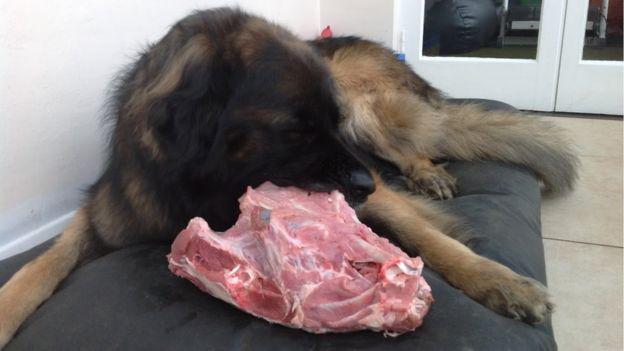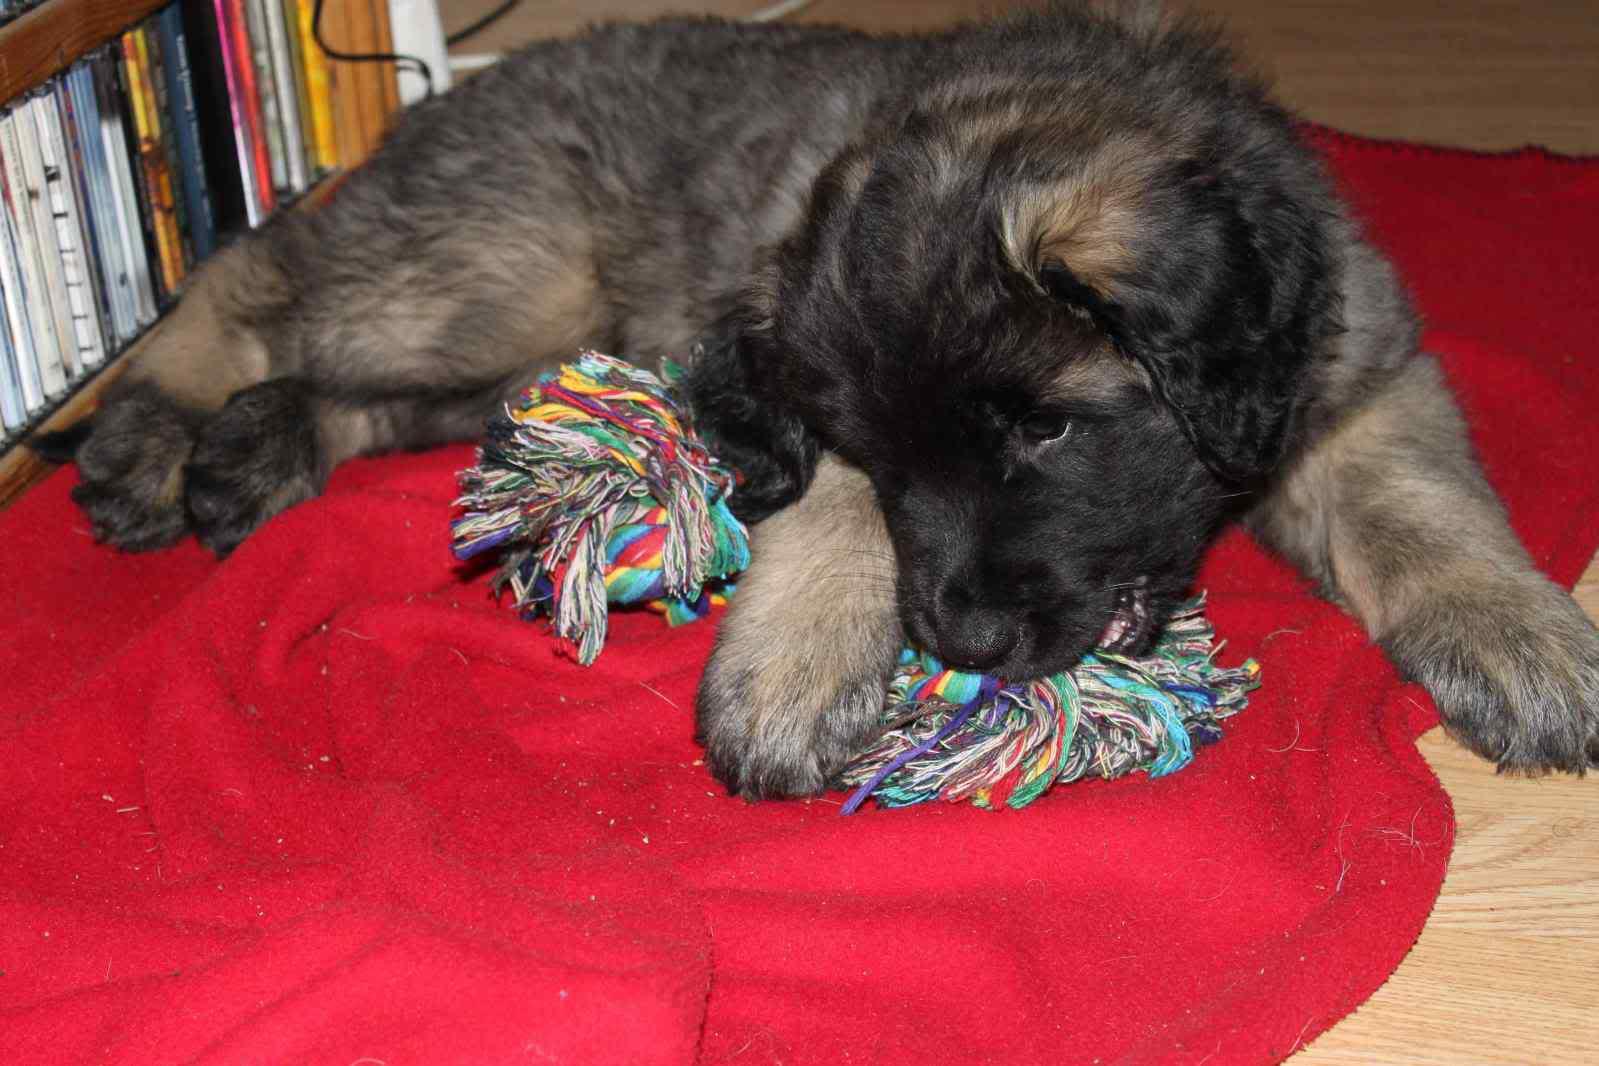The first image is the image on the left, the second image is the image on the right. Evaluate the accuracy of this statement regarding the images: "There is an adult dog chewing on the animal flesh.". Is it true? Answer yes or no. Yes. The first image is the image on the left, the second image is the image on the right. Analyze the images presented: Is the assertion "The left image shows a reclining big-breed adult dog chewing on some type of raw meat, and the right image shows at least one big-breed puppy." valid? Answer yes or no. Yes. 